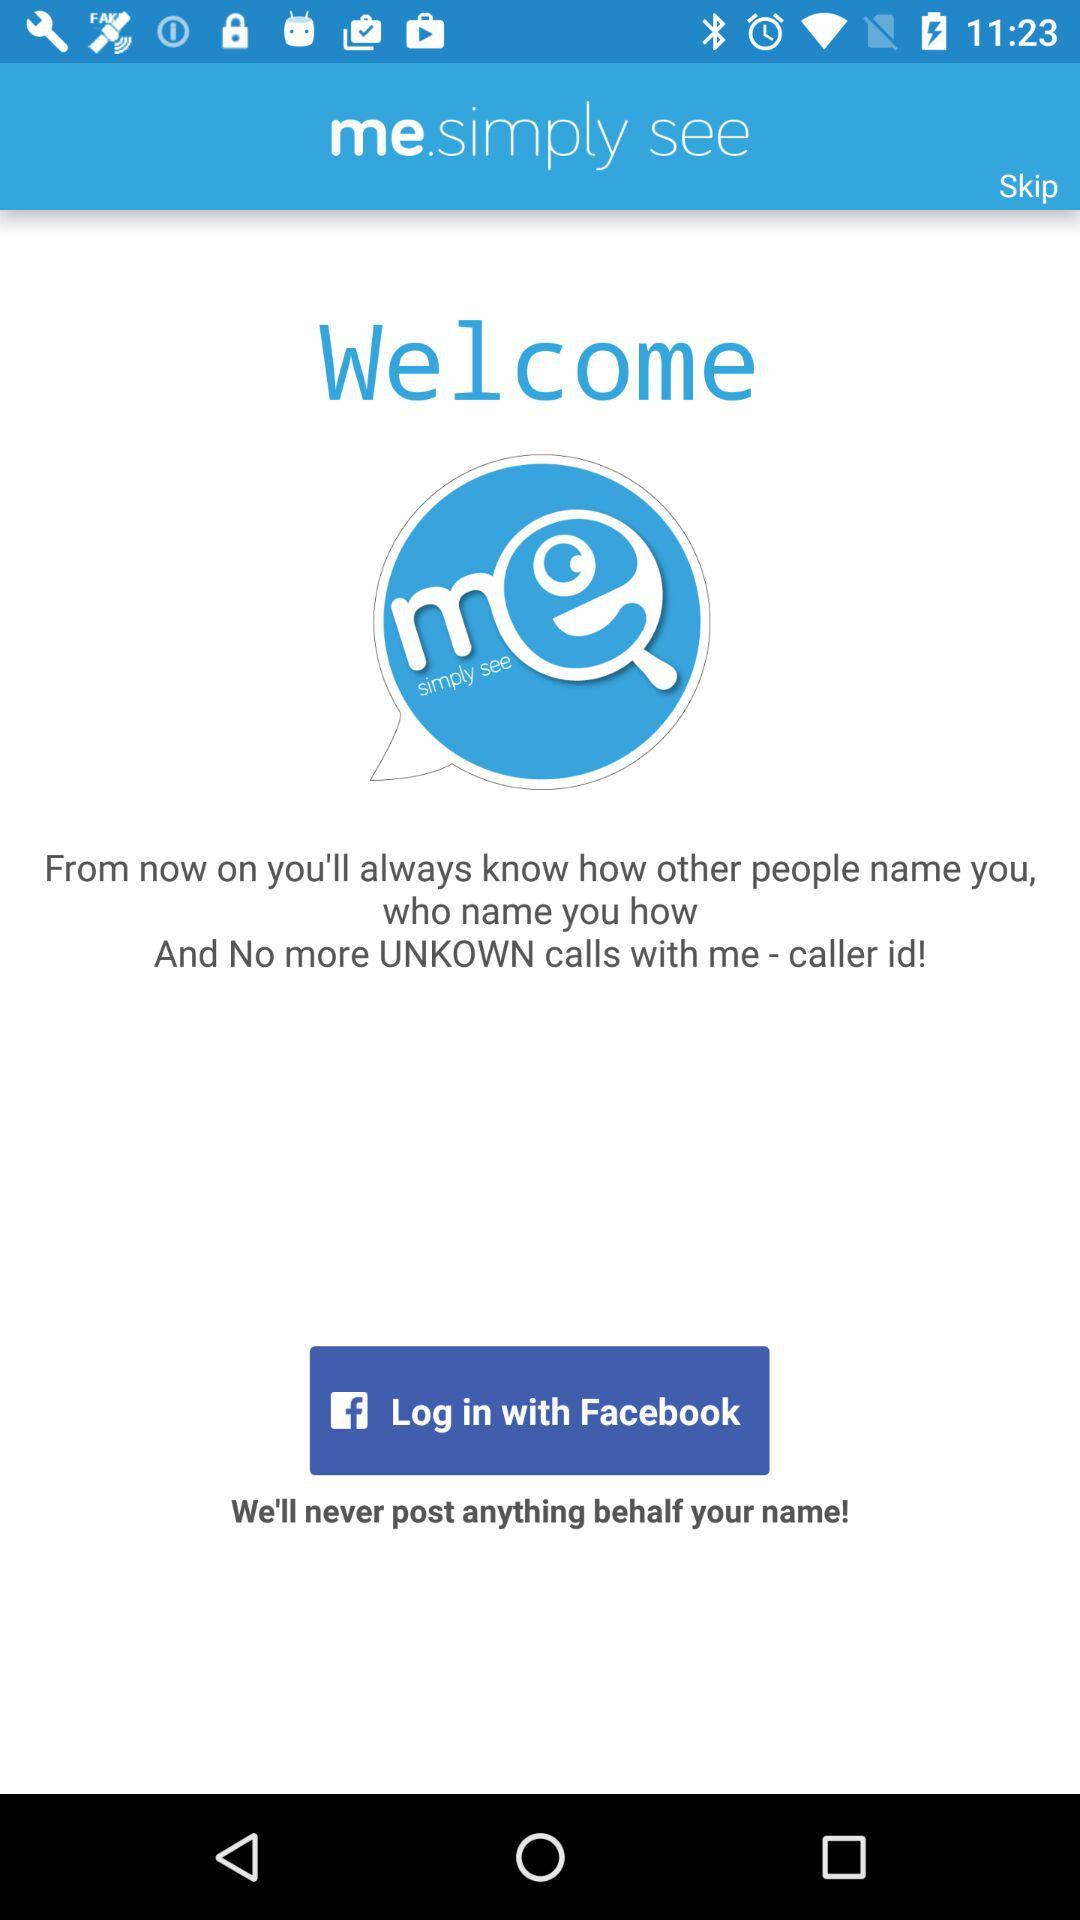How can we log in? You can log in with "Facebook". 